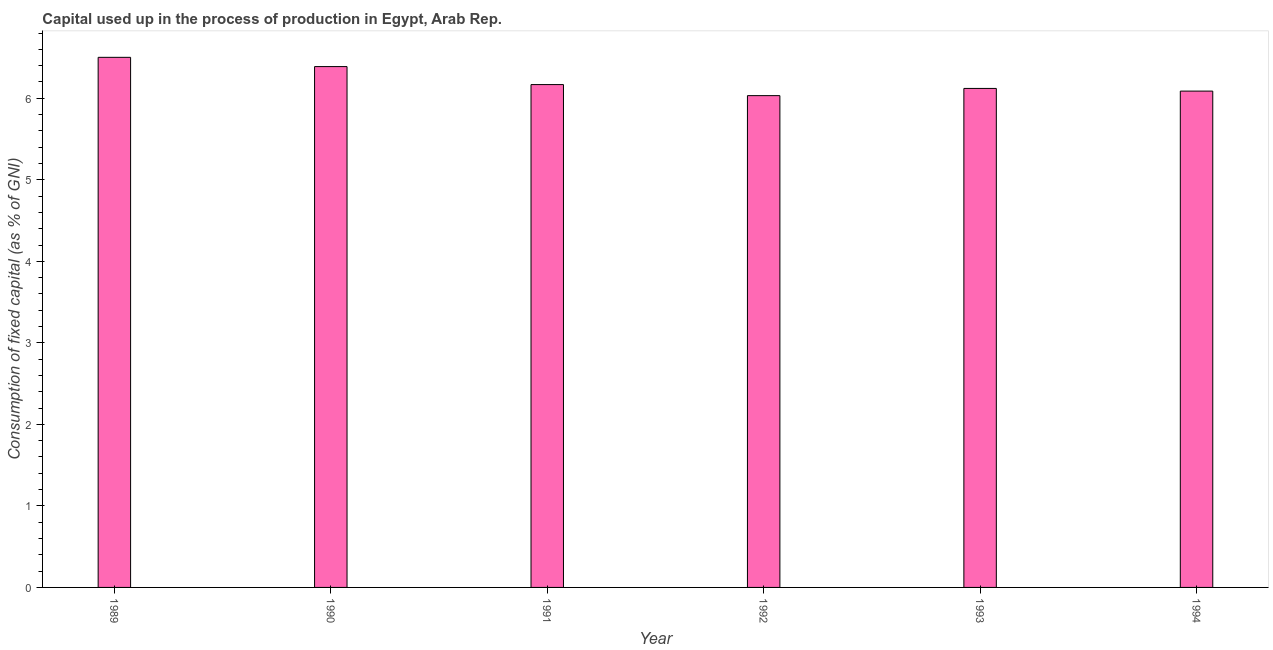Does the graph contain any zero values?
Provide a short and direct response. No. What is the title of the graph?
Give a very brief answer. Capital used up in the process of production in Egypt, Arab Rep. What is the label or title of the X-axis?
Provide a short and direct response. Year. What is the label or title of the Y-axis?
Ensure brevity in your answer.  Consumption of fixed capital (as % of GNI). What is the consumption of fixed capital in 1989?
Ensure brevity in your answer.  6.5. Across all years, what is the maximum consumption of fixed capital?
Make the answer very short. 6.5. Across all years, what is the minimum consumption of fixed capital?
Ensure brevity in your answer.  6.03. In which year was the consumption of fixed capital maximum?
Provide a succinct answer. 1989. What is the sum of the consumption of fixed capital?
Your answer should be compact. 37.3. What is the difference between the consumption of fixed capital in 1989 and 1994?
Give a very brief answer. 0.41. What is the average consumption of fixed capital per year?
Offer a terse response. 6.22. What is the median consumption of fixed capital?
Provide a succinct answer. 6.14. What is the ratio of the consumption of fixed capital in 1993 to that in 1994?
Your answer should be very brief. 1. What is the difference between the highest and the second highest consumption of fixed capital?
Ensure brevity in your answer.  0.11. What is the difference between the highest and the lowest consumption of fixed capital?
Offer a very short reply. 0.47. In how many years, is the consumption of fixed capital greater than the average consumption of fixed capital taken over all years?
Offer a terse response. 2. How many bars are there?
Make the answer very short. 6. Are all the bars in the graph horizontal?
Your answer should be compact. No. What is the Consumption of fixed capital (as % of GNI) of 1989?
Ensure brevity in your answer.  6.5. What is the Consumption of fixed capital (as % of GNI) of 1990?
Your answer should be very brief. 6.39. What is the Consumption of fixed capital (as % of GNI) in 1991?
Your answer should be compact. 6.17. What is the Consumption of fixed capital (as % of GNI) of 1992?
Offer a terse response. 6.03. What is the Consumption of fixed capital (as % of GNI) in 1993?
Provide a succinct answer. 6.12. What is the Consumption of fixed capital (as % of GNI) of 1994?
Ensure brevity in your answer.  6.09. What is the difference between the Consumption of fixed capital (as % of GNI) in 1989 and 1990?
Make the answer very short. 0.11. What is the difference between the Consumption of fixed capital (as % of GNI) in 1989 and 1991?
Ensure brevity in your answer.  0.33. What is the difference between the Consumption of fixed capital (as % of GNI) in 1989 and 1992?
Your response must be concise. 0.47. What is the difference between the Consumption of fixed capital (as % of GNI) in 1989 and 1993?
Provide a succinct answer. 0.38. What is the difference between the Consumption of fixed capital (as % of GNI) in 1989 and 1994?
Keep it short and to the point. 0.41. What is the difference between the Consumption of fixed capital (as % of GNI) in 1990 and 1991?
Provide a short and direct response. 0.22. What is the difference between the Consumption of fixed capital (as % of GNI) in 1990 and 1992?
Provide a short and direct response. 0.36. What is the difference between the Consumption of fixed capital (as % of GNI) in 1990 and 1993?
Your answer should be compact. 0.27. What is the difference between the Consumption of fixed capital (as % of GNI) in 1990 and 1994?
Give a very brief answer. 0.3. What is the difference between the Consumption of fixed capital (as % of GNI) in 1991 and 1992?
Your answer should be compact. 0.14. What is the difference between the Consumption of fixed capital (as % of GNI) in 1991 and 1993?
Provide a short and direct response. 0.05. What is the difference between the Consumption of fixed capital (as % of GNI) in 1991 and 1994?
Ensure brevity in your answer.  0.08. What is the difference between the Consumption of fixed capital (as % of GNI) in 1992 and 1993?
Make the answer very short. -0.09. What is the difference between the Consumption of fixed capital (as % of GNI) in 1992 and 1994?
Provide a short and direct response. -0.06. What is the difference between the Consumption of fixed capital (as % of GNI) in 1993 and 1994?
Keep it short and to the point. 0.03. What is the ratio of the Consumption of fixed capital (as % of GNI) in 1989 to that in 1991?
Your answer should be very brief. 1.05. What is the ratio of the Consumption of fixed capital (as % of GNI) in 1989 to that in 1992?
Offer a very short reply. 1.08. What is the ratio of the Consumption of fixed capital (as % of GNI) in 1989 to that in 1993?
Provide a short and direct response. 1.06. What is the ratio of the Consumption of fixed capital (as % of GNI) in 1989 to that in 1994?
Make the answer very short. 1.07. What is the ratio of the Consumption of fixed capital (as % of GNI) in 1990 to that in 1991?
Your answer should be very brief. 1.04. What is the ratio of the Consumption of fixed capital (as % of GNI) in 1990 to that in 1992?
Make the answer very short. 1.06. What is the ratio of the Consumption of fixed capital (as % of GNI) in 1990 to that in 1993?
Your answer should be very brief. 1.04. What is the ratio of the Consumption of fixed capital (as % of GNI) in 1990 to that in 1994?
Offer a very short reply. 1.05. What is the ratio of the Consumption of fixed capital (as % of GNI) in 1991 to that in 1992?
Make the answer very short. 1.02. What is the ratio of the Consumption of fixed capital (as % of GNI) in 1991 to that in 1994?
Ensure brevity in your answer.  1.01. What is the ratio of the Consumption of fixed capital (as % of GNI) in 1992 to that in 1994?
Give a very brief answer. 0.99. 